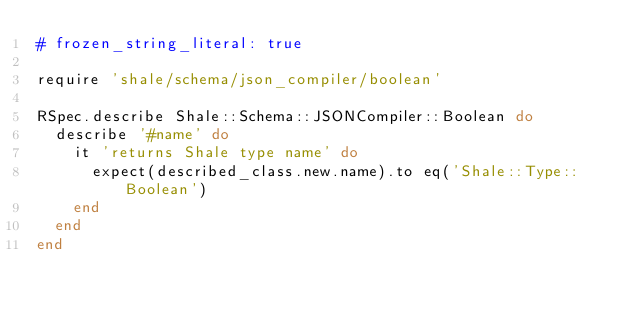<code> <loc_0><loc_0><loc_500><loc_500><_Ruby_># frozen_string_literal: true

require 'shale/schema/json_compiler/boolean'

RSpec.describe Shale::Schema::JSONCompiler::Boolean do
  describe '#name' do
    it 'returns Shale type name' do
      expect(described_class.new.name).to eq('Shale::Type::Boolean')
    end
  end
end
</code> 